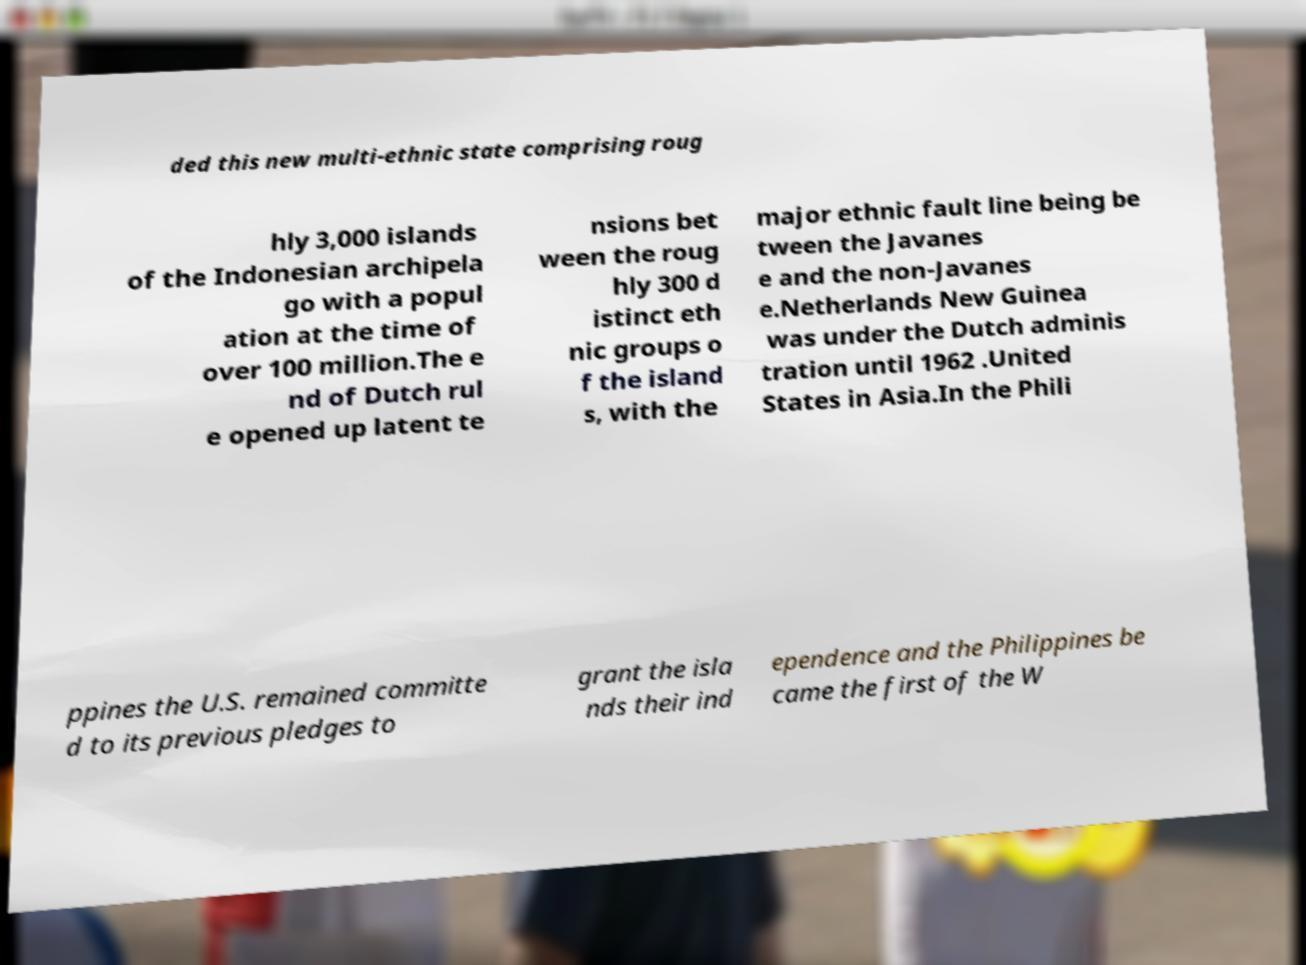I need the written content from this picture converted into text. Can you do that? ded this new multi-ethnic state comprising roug hly 3,000 islands of the Indonesian archipela go with a popul ation at the time of over 100 million.The e nd of Dutch rul e opened up latent te nsions bet ween the roug hly 300 d istinct eth nic groups o f the island s, with the major ethnic fault line being be tween the Javanes e and the non-Javanes e.Netherlands New Guinea was under the Dutch adminis tration until 1962 .United States in Asia.In the Phili ppines the U.S. remained committe d to its previous pledges to grant the isla nds their ind ependence and the Philippines be came the first of the W 